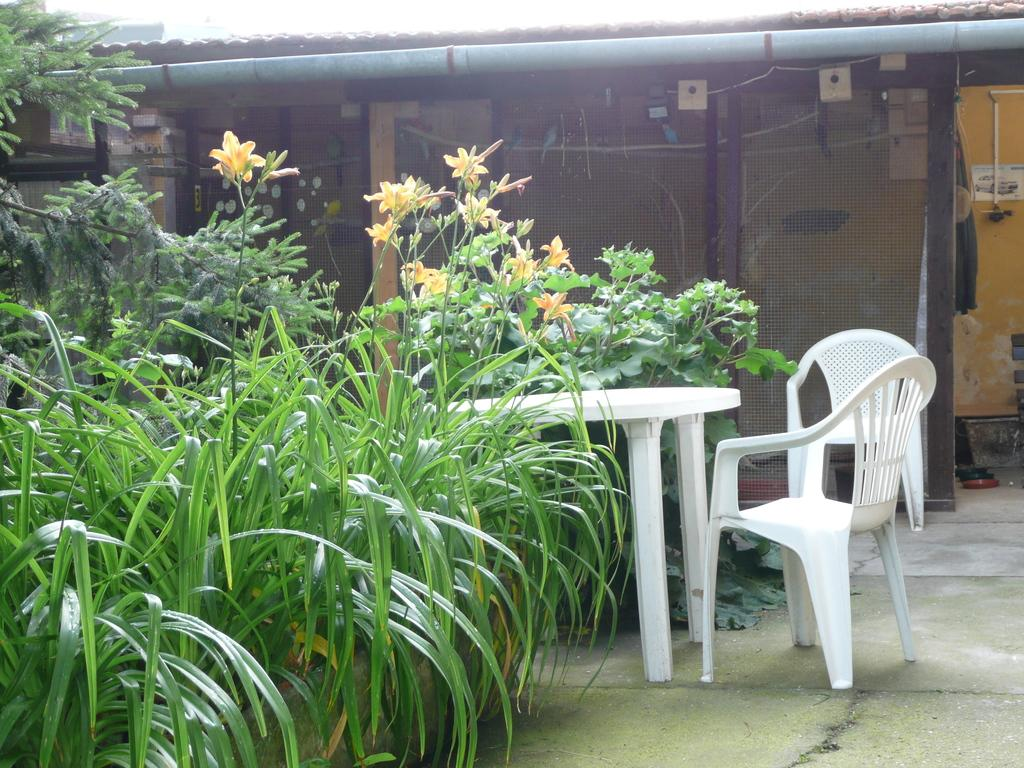What type of living organisms can be seen in the image? Plants can be seen in the image. What type of structure is present in the image? There is a house in the image. What piece of furniture is visible in the image? There is a table in the image. How many chairs are present in the image? There are two chairs in the image. What type of straw can be seen blowing in the wind in the image? There is no straw present in the image, and therefore no such activity can be observed. 